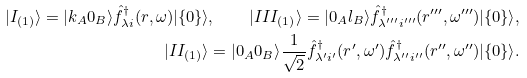<formula> <loc_0><loc_0><loc_500><loc_500>| I _ { ( 1 ) } \rangle = | k _ { A } 0 _ { B } \rangle \hat { f } _ { \lambda i } ^ { \dagger } ( r , \omega ) | \{ 0 \} \rangle , \quad | I I I _ { ( 1 ) } \rangle = | 0 _ { A } l _ { B } \rangle \hat { f } _ { \lambda ^ { \prime \prime \prime } i ^ { \prime \prime \prime } } ^ { \dagger } ( r ^ { \prime \prime \prime } , \omega ^ { \prime \prime \prime } ) | \{ 0 \} \rangle , \\ | I I _ { ( 1 ) } \rangle = | 0 _ { A } 0 _ { B } \rangle { \frac { 1 } { \sqrt { 2 } } } \hat { f } _ { \lambda ^ { \prime } i ^ { \prime } } ^ { \dagger } ( r ^ { \prime } , \omega ^ { \prime } ) \hat { f } _ { \lambda ^ { \prime \prime } i ^ { \prime \prime } } ^ { \dagger } ( r ^ { \prime \prime } , \omega ^ { \prime \prime } ) | \{ 0 \} \rangle .</formula> 